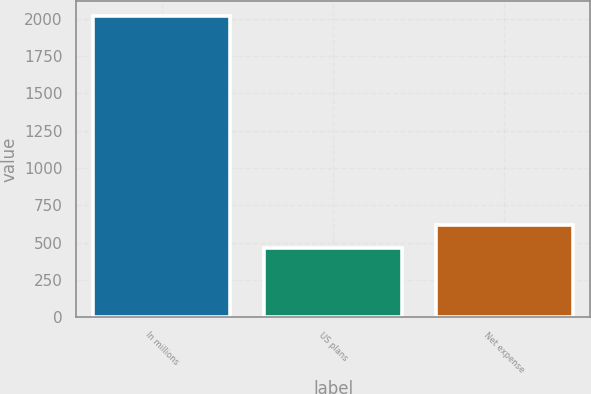Convert chart. <chart><loc_0><loc_0><loc_500><loc_500><bar_chart><fcel>In millions<fcel>US plans<fcel>Net expense<nl><fcel>2015<fcel>461<fcel>616.4<nl></chart> 